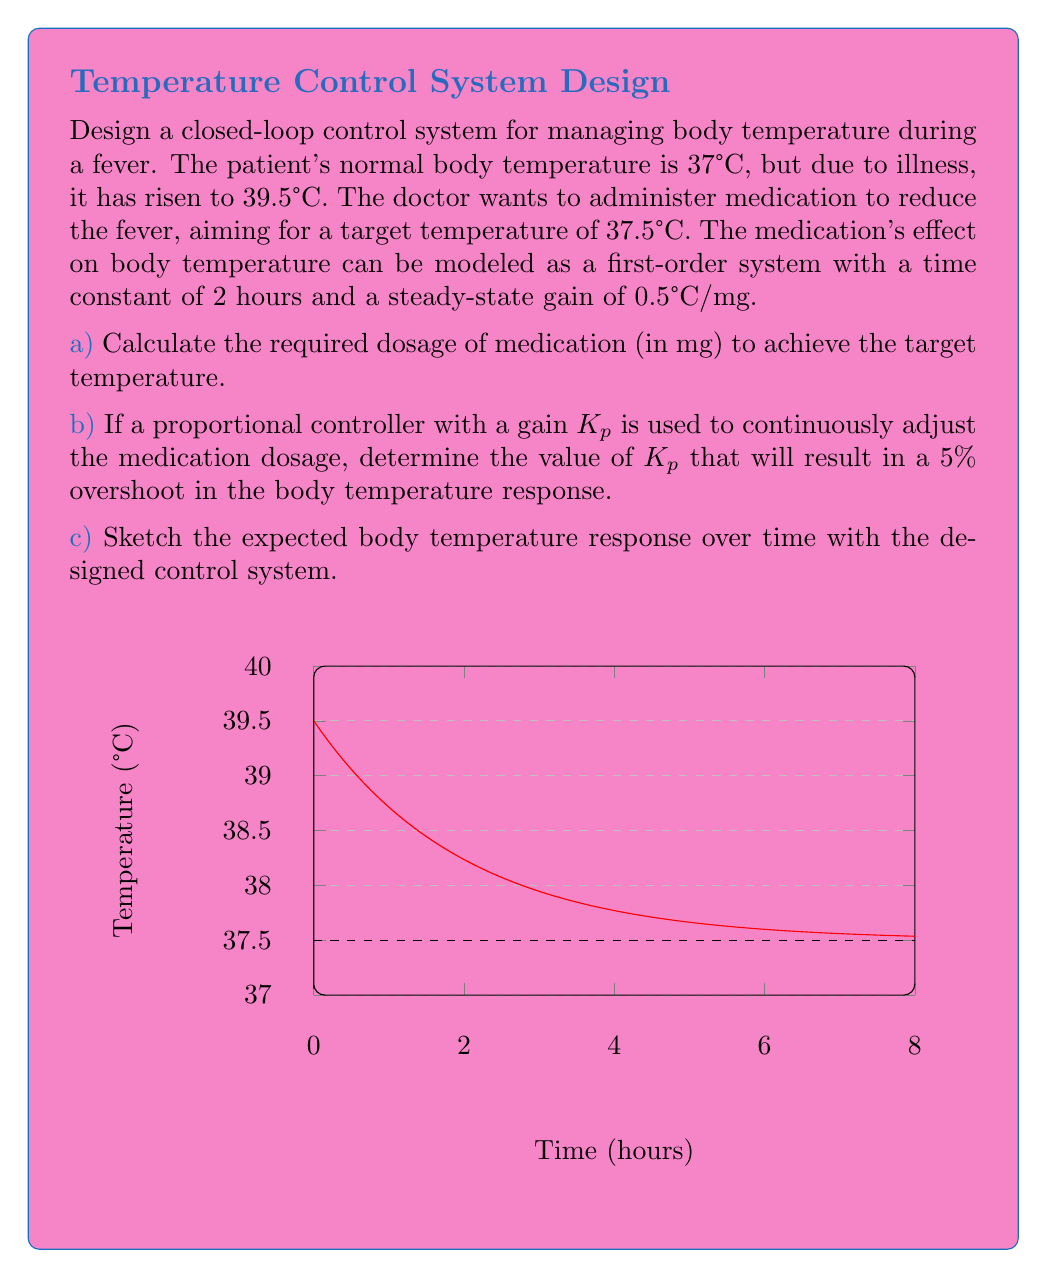Show me your answer to this math problem. Let's approach this problem step by step:

a) To calculate the required dosage:
   1. Temperature change needed = Target temp - Current temp
      $\Delta T = 37.5°C - 39.5°C = -2°C$
   2. Using the steady-state gain: $\Delta T = 0.5°C/mg \times \text{Dose}$
   3. Rearranging: $\text{Dose} = \frac{\Delta T}{0.5°C/mg} = \frac{-2°C}{0.5°C/mg} = -4 \text{ mg}$

b) To determine $K_p$ for 5% overshoot:
   1. For a first-order system with a proportional controller, the closed-loop transfer function is:
      $G(s) = \frac{K_p K}{1 + K_p K} \cdot \frac{1}{\tau s + 1}$
      where $K = 0.5°C/mg$ and $\tau = 2 \text{ hours}$
   2. The percent overshoot (PO) for a first-order system is given by:
      $PO = e^{-\pi / \sqrt{1 - \zeta^2}} \times 100\%$
      where $\zeta$ is the damping ratio
   3. For 5% overshoot: $0.05 = e^{-\pi / \sqrt{1 - \zeta^2}}$
   4. Solving for $\zeta$: $\zeta \approx 0.69$
   5. The damping ratio is related to $K_p$ by:
      $\zeta = \frac{1}{2\sqrt{K_p K}}$
   6. Substituting and solving:
      $0.69 = \frac{1}{2\sqrt{K_p \cdot 0.5}}$
      $K_p = \frac{1}{4 \cdot 0.69^2 \cdot 0.5} \approx 2.1 \text{ mg/°C}$

c) The sketch shows the expected body temperature response over time. It starts at 39.5°C, quickly drops towards the target temperature of 37.5°C with a small overshoot (5%), and then settles at the target temperature.
Answer: a) -4 mg
b) $K_p \approx 2.1 \text{ mg/°C}$
c) See sketch in question 